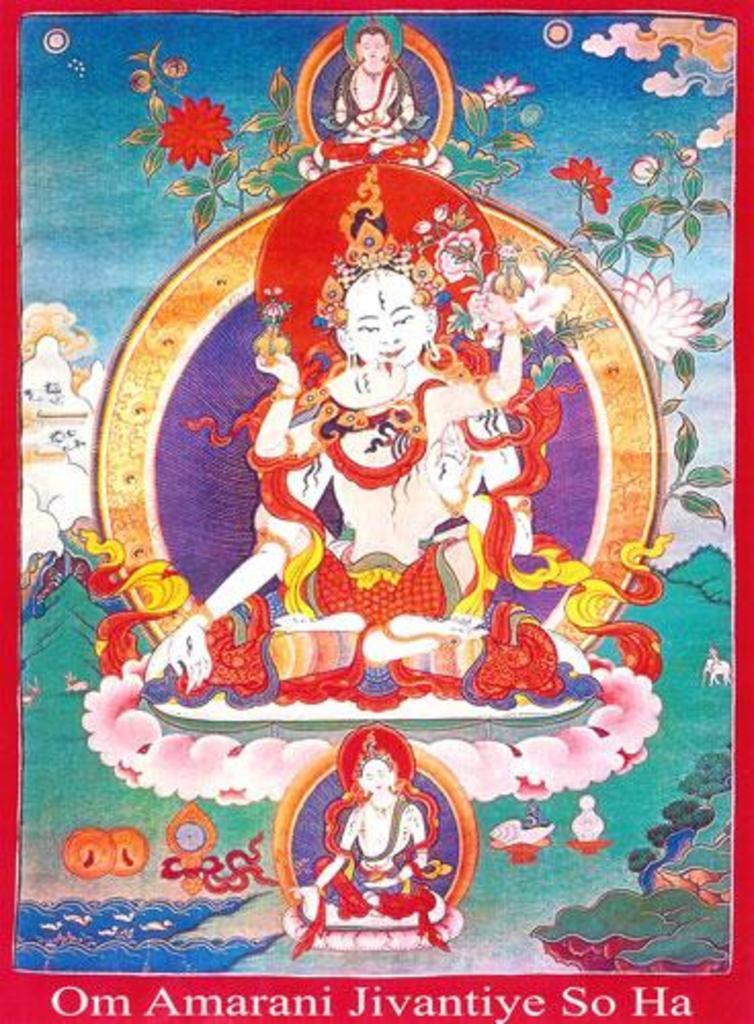In one or two sentences, can you explain what this image depicts? In this image I can see a poster and on the poster I can see a person is sitting. I can see few mountains, few flowers which are pink and red in color, the sky and few leafs which are green in color. 